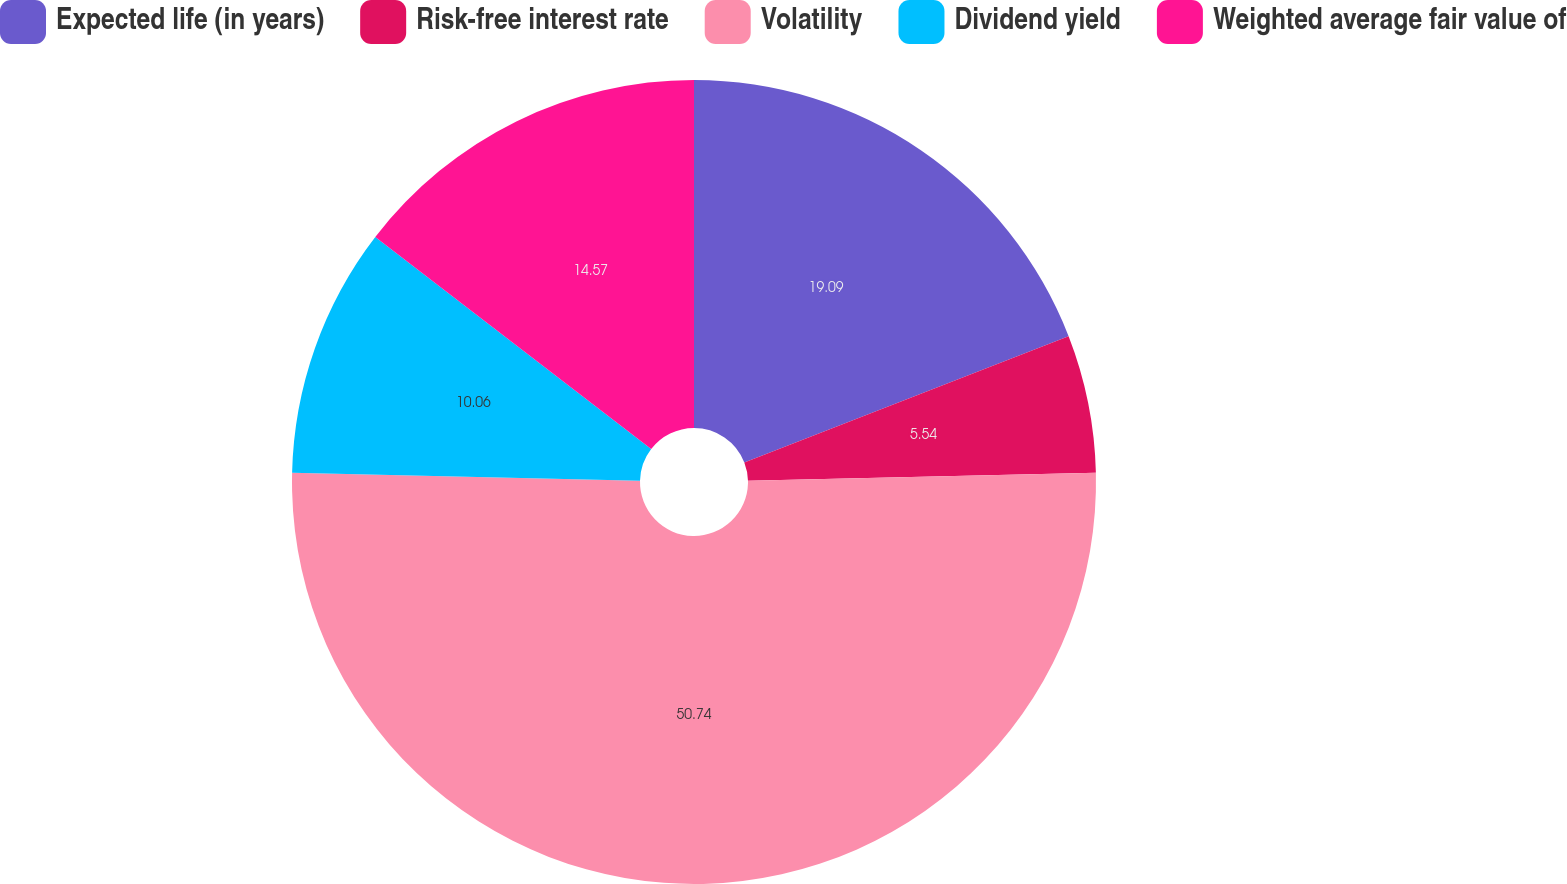Convert chart. <chart><loc_0><loc_0><loc_500><loc_500><pie_chart><fcel>Expected life (in years)<fcel>Risk-free interest rate<fcel>Volatility<fcel>Dividend yield<fcel>Weighted average fair value of<nl><fcel>19.09%<fcel>5.54%<fcel>50.74%<fcel>10.06%<fcel>14.57%<nl></chart> 